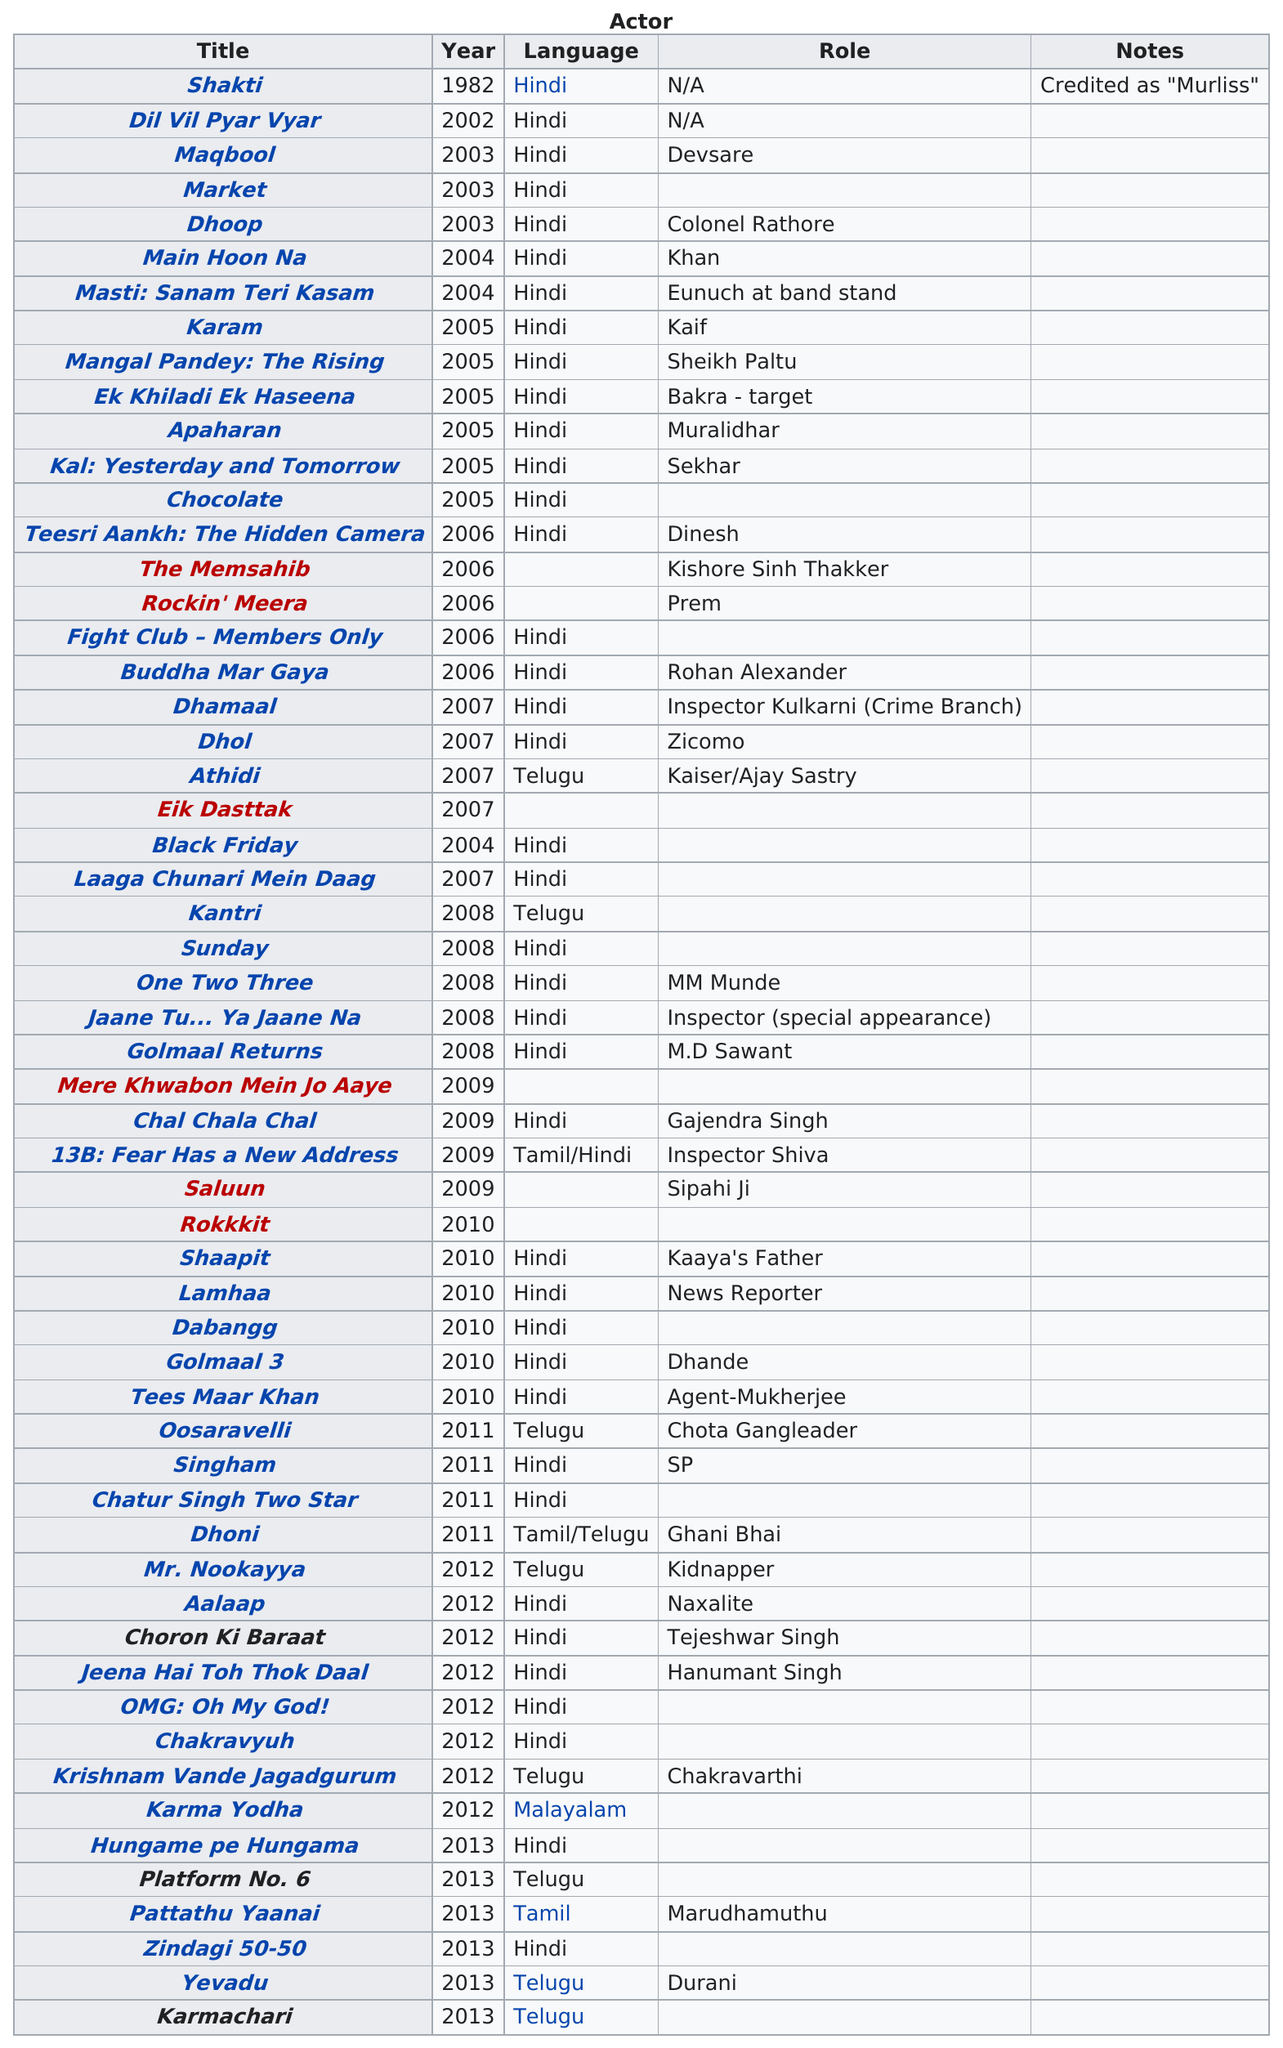Outline some significant characteristics in this image. There are 57 titles listed. This actor has had a total of 36 roles. Karam Karam" is a phrase that translates to "What is there to be done." In the context of "Mangal Pandey: The Rising," it is likely that the title listed after "Karam Karam" refers to the title of the movie. It is not the case that Maqbool has longer notes than Shakti. In 2005, there were 6 titles listed. 